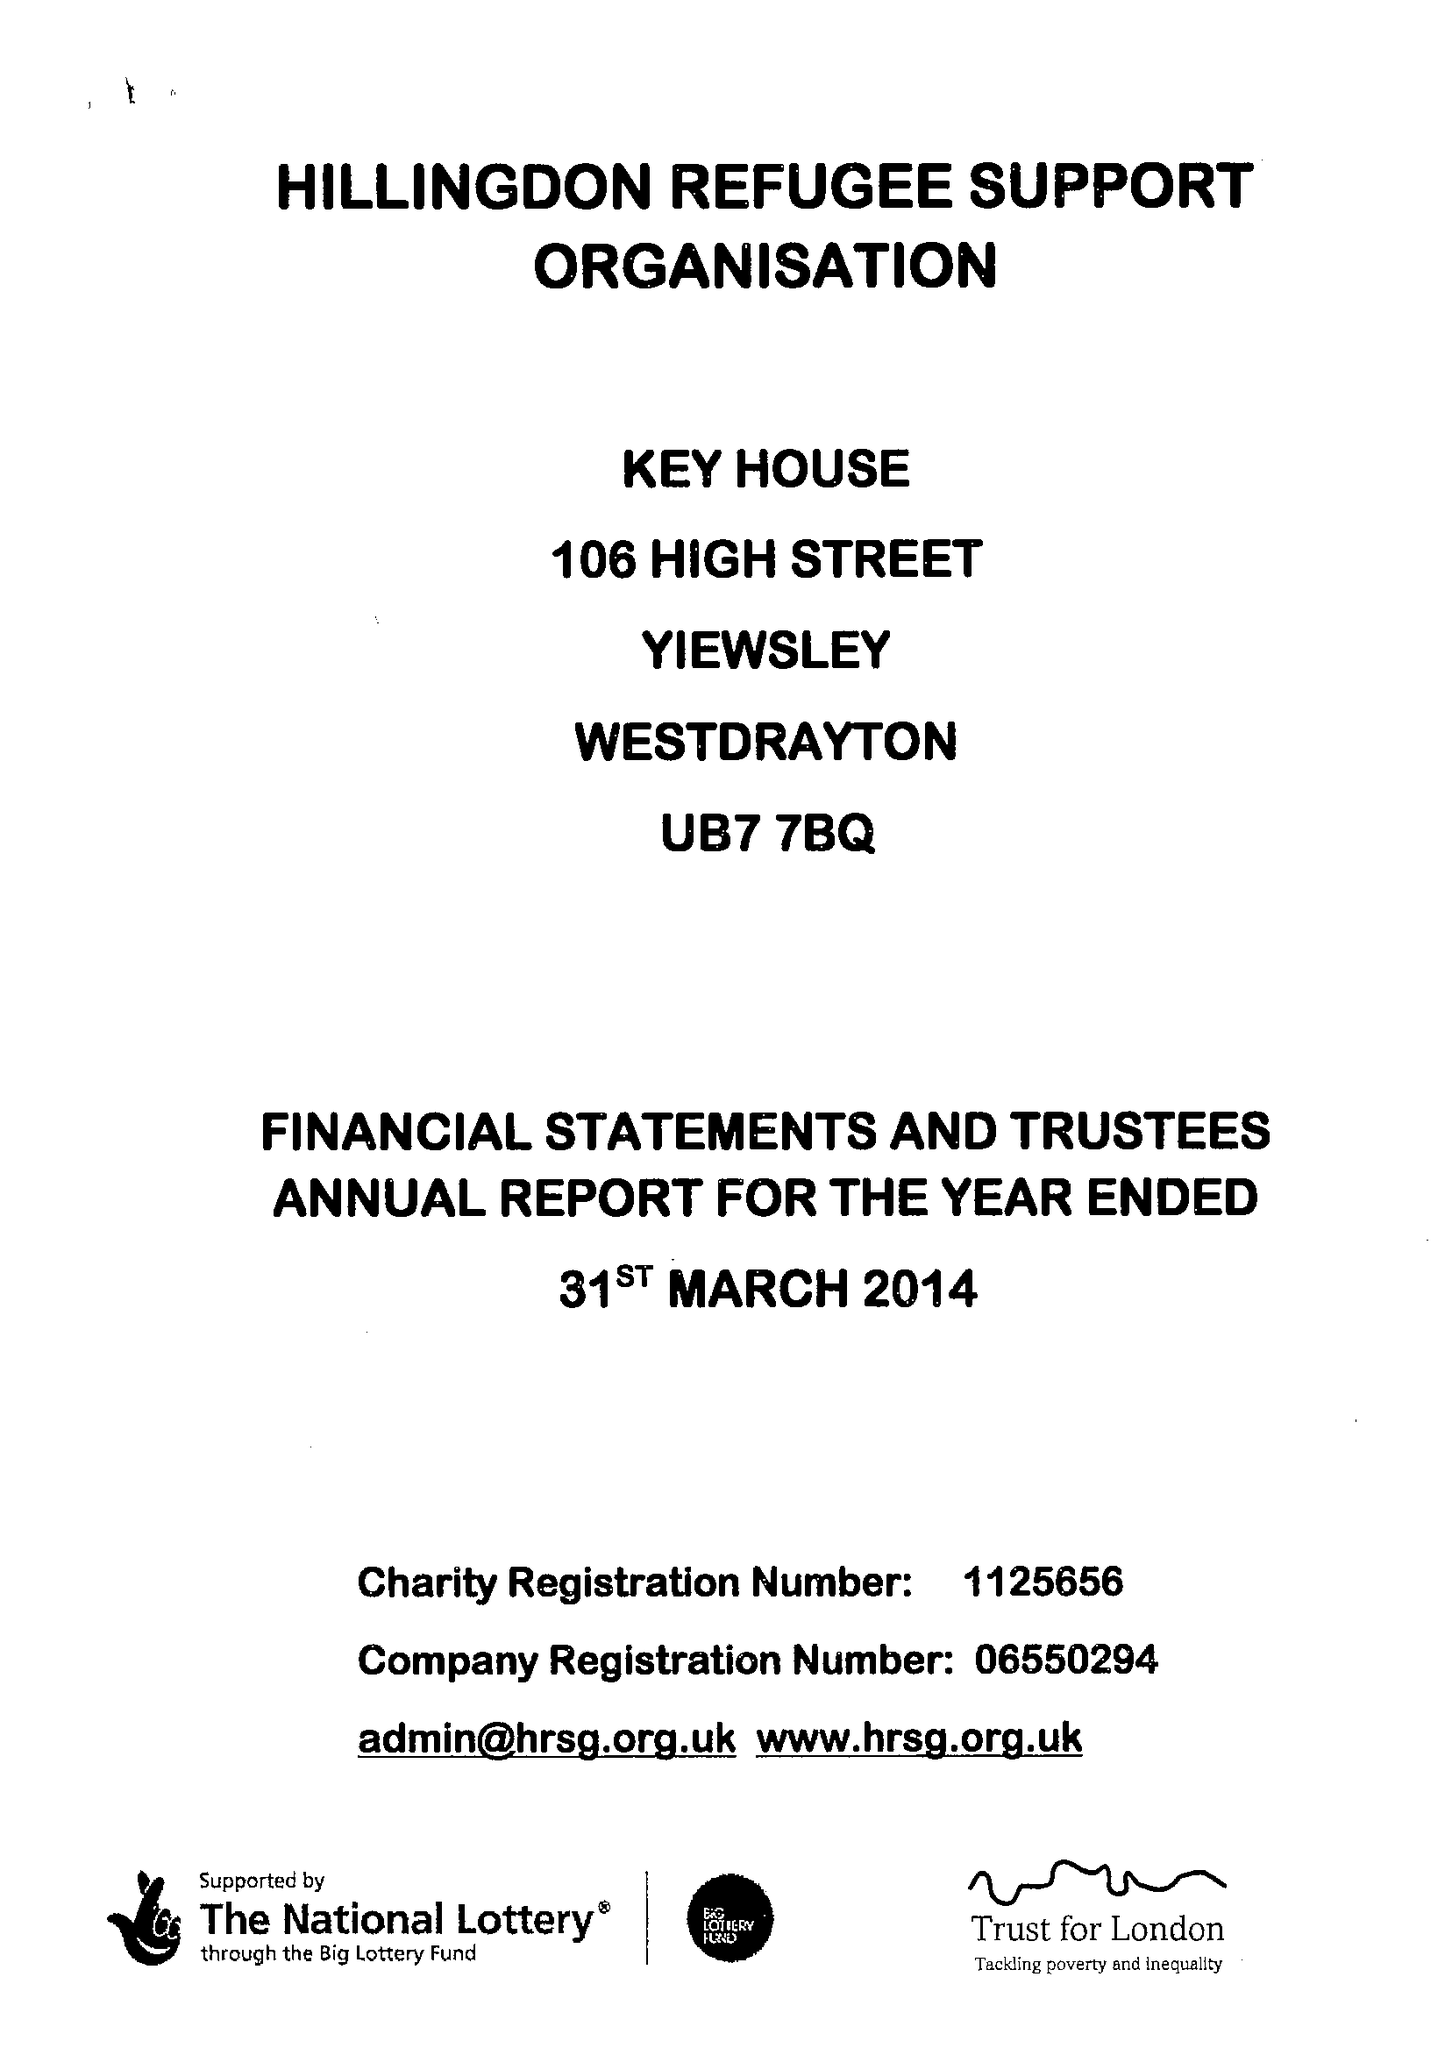What is the value for the address__street_line?
Answer the question using a single word or phrase. 106 HIGH STREET 